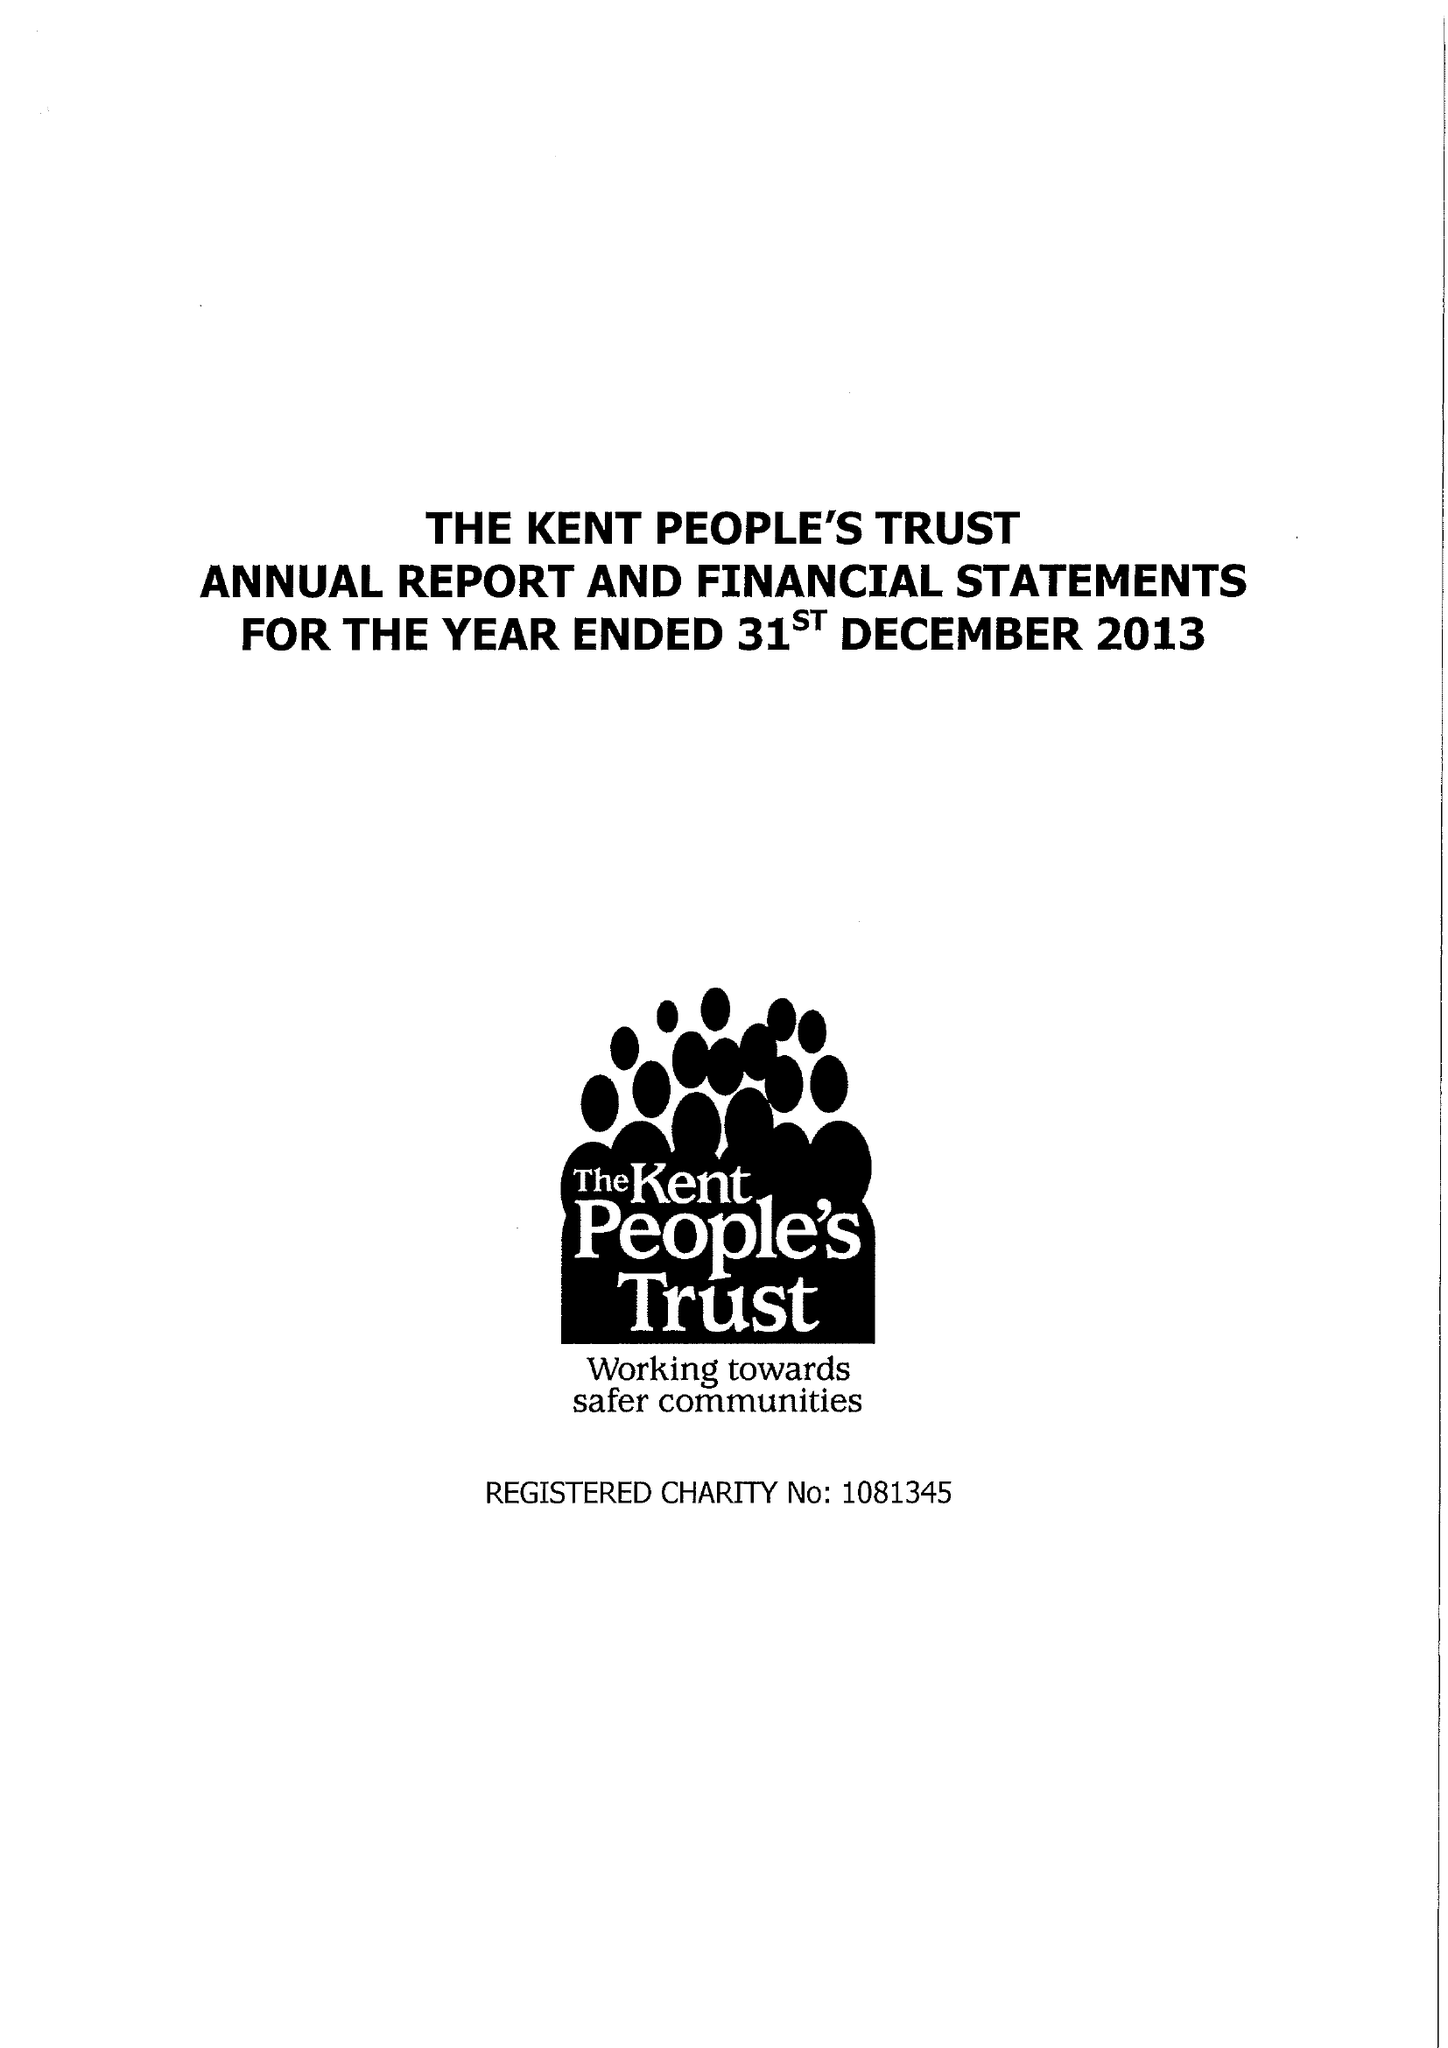What is the value for the address__street_line?
Answer the question using a single word or phrase. SUTTON ROAD 